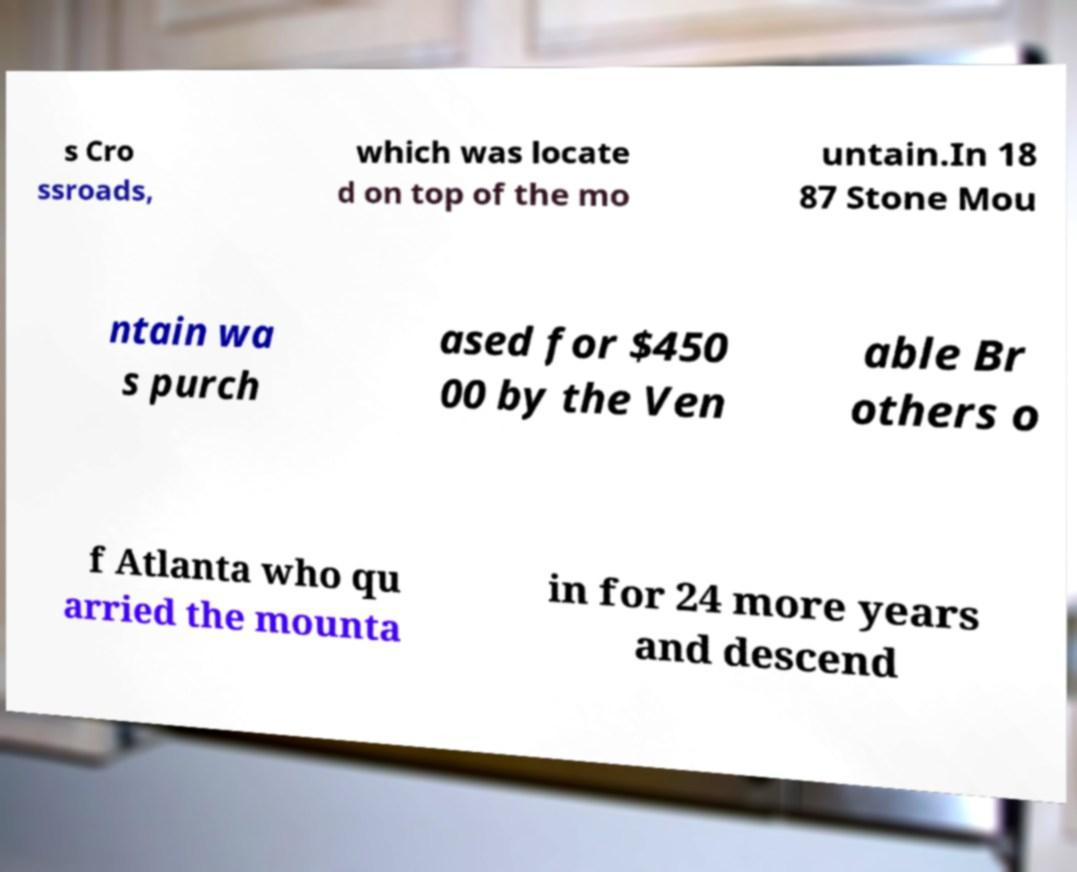Please read and relay the text visible in this image. What does it say? s Cro ssroads, which was locate d on top of the mo untain.In 18 87 Stone Mou ntain wa s purch ased for $450 00 by the Ven able Br others o f Atlanta who qu arried the mounta in for 24 more years and descend 